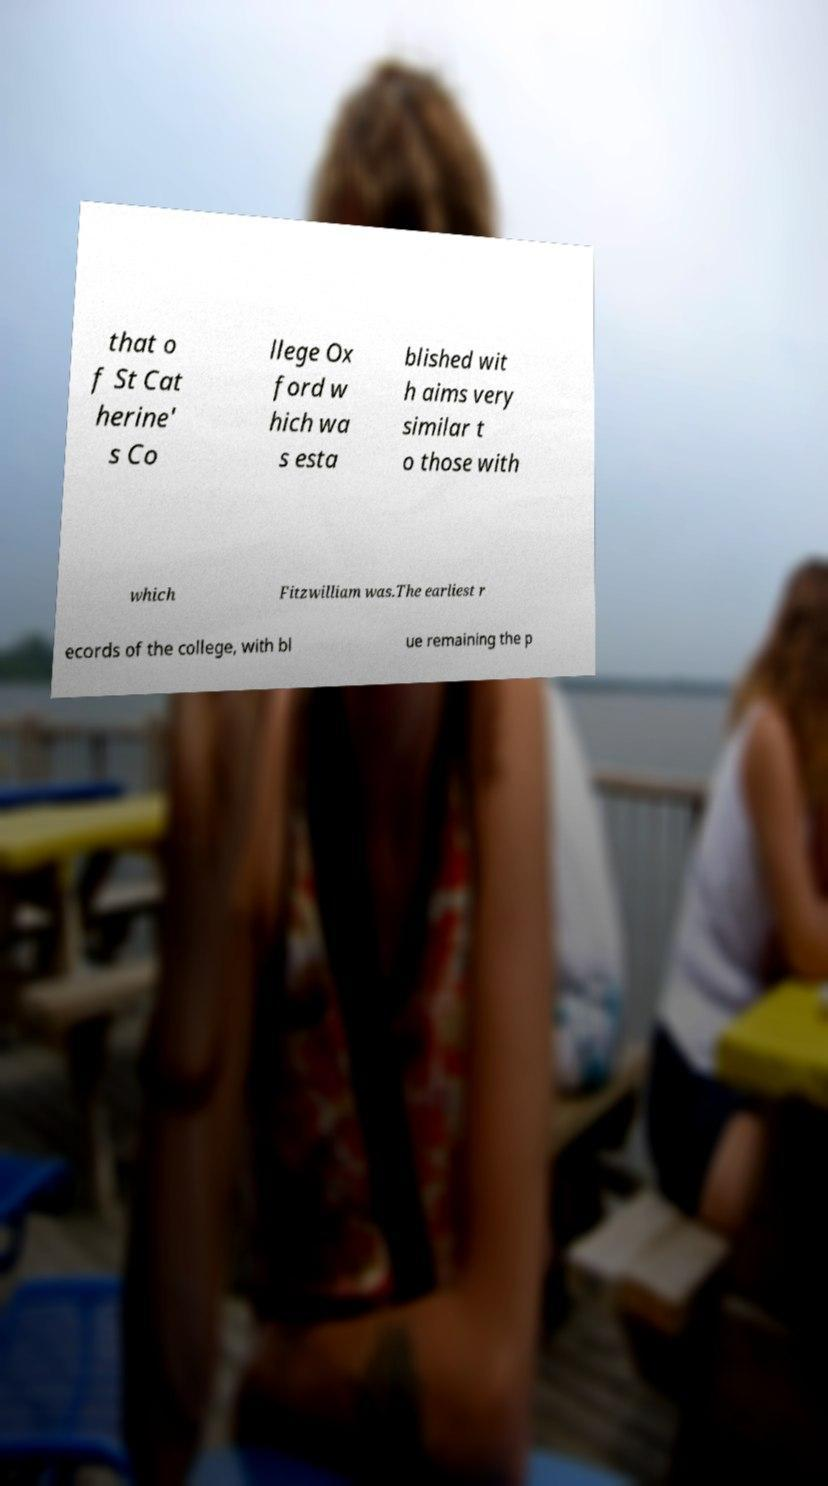Please read and relay the text visible in this image. What does it say? that o f St Cat herine' s Co llege Ox ford w hich wa s esta blished wit h aims very similar t o those with which Fitzwilliam was.The earliest r ecords of the college, with bl ue remaining the p 